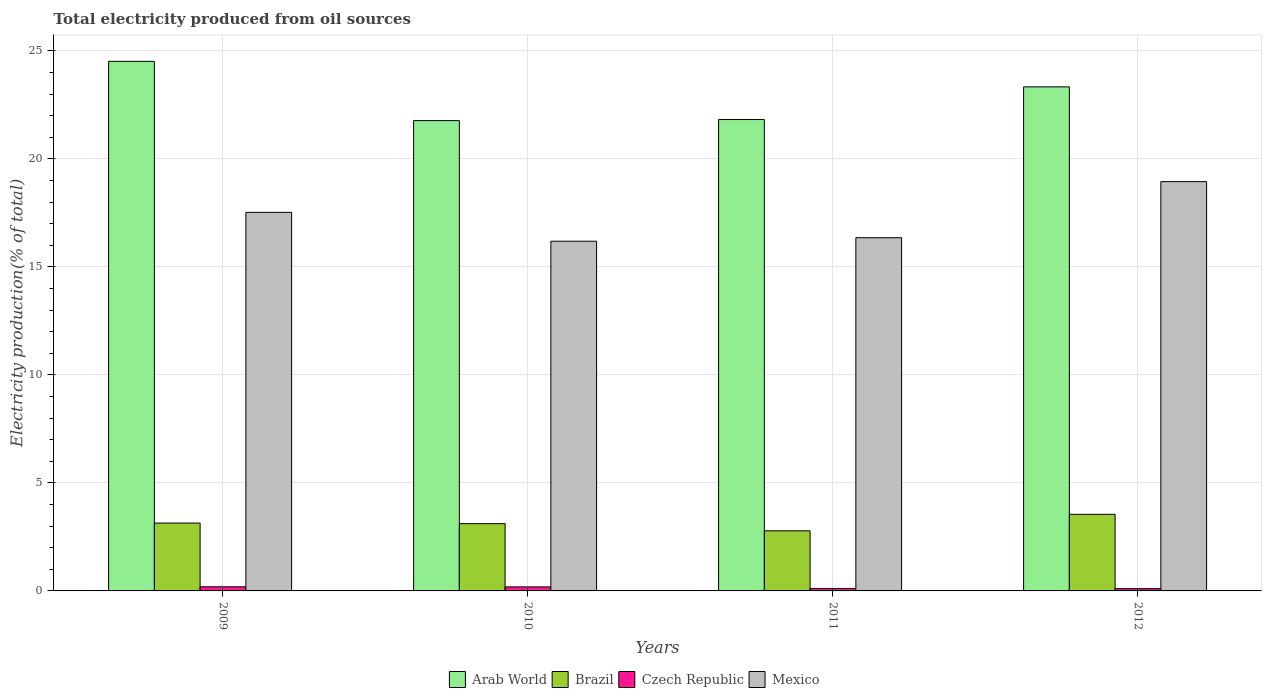How many different coloured bars are there?
Give a very brief answer. 4. How many groups of bars are there?
Ensure brevity in your answer.  4. Are the number of bars per tick equal to the number of legend labels?
Your answer should be very brief. Yes. Are the number of bars on each tick of the X-axis equal?
Offer a very short reply. Yes. How many bars are there on the 3rd tick from the left?
Provide a short and direct response. 4. In how many cases, is the number of bars for a given year not equal to the number of legend labels?
Offer a very short reply. 0. What is the total electricity produced in Brazil in 2012?
Provide a short and direct response. 3.55. Across all years, what is the maximum total electricity produced in Czech Republic?
Ensure brevity in your answer.  0.19. Across all years, what is the minimum total electricity produced in Czech Republic?
Your answer should be very brief. 0.1. In which year was the total electricity produced in Arab World maximum?
Keep it short and to the point. 2009. In which year was the total electricity produced in Arab World minimum?
Give a very brief answer. 2010. What is the total total electricity produced in Czech Republic in the graph?
Ensure brevity in your answer.  0.6. What is the difference between the total electricity produced in Arab World in 2011 and that in 2012?
Provide a succinct answer. -1.51. What is the difference between the total electricity produced in Czech Republic in 2011 and the total electricity produced in Mexico in 2010?
Provide a succinct answer. -16.07. What is the average total electricity produced in Arab World per year?
Your answer should be compact. 22.86. In the year 2011, what is the difference between the total electricity produced in Mexico and total electricity produced in Brazil?
Your answer should be compact. 13.57. What is the ratio of the total electricity produced in Arab World in 2011 to that in 2012?
Make the answer very short. 0.94. Is the difference between the total electricity produced in Mexico in 2009 and 2011 greater than the difference between the total electricity produced in Brazil in 2009 and 2011?
Give a very brief answer. Yes. What is the difference between the highest and the second highest total electricity produced in Mexico?
Give a very brief answer. 1.42. What is the difference between the highest and the lowest total electricity produced in Czech Republic?
Keep it short and to the point. 0.09. Is the sum of the total electricity produced in Czech Republic in 2009 and 2011 greater than the maximum total electricity produced in Arab World across all years?
Your response must be concise. No. Is it the case that in every year, the sum of the total electricity produced in Czech Republic and total electricity produced in Mexico is greater than the sum of total electricity produced in Arab World and total electricity produced in Brazil?
Give a very brief answer. Yes. What does the 4th bar from the left in 2009 represents?
Keep it short and to the point. Mexico. What does the 4th bar from the right in 2012 represents?
Offer a very short reply. Arab World. How many bars are there?
Make the answer very short. 16. Are all the bars in the graph horizontal?
Provide a succinct answer. No. What is the difference between two consecutive major ticks on the Y-axis?
Offer a very short reply. 5. Does the graph contain any zero values?
Provide a succinct answer. No. What is the title of the graph?
Provide a short and direct response. Total electricity produced from oil sources. What is the label or title of the X-axis?
Your response must be concise. Years. What is the label or title of the Y-axis?
Offer a very short reply. Electricity production(% of total). What is the Electricity production(% of total) in Arab World in 2009?
Provide a succinct answer. 24.51. What is the Electricity production(% of total) in Brazil in 2009?
Make the answer very short. 3.14. What is the Electricity production(% of total) in Czech Republic in 2009?
Provide a short and direct response. 0.19. What is the Electricity production(% of total) of Mexico in 2009?
Offer a very short reply. 17.52. What is the Electricity production(% of total) in Arab World in 2010?
Give a very brief answer. 21.77. What is the Electricity production(% of total) of Brazil in 2010?
Ensure brevity in your answer.  3.11. What is the Electricity production(% of total) of Czech Republic in 2010?
Your answer should be very brief. 0.19. What is the Electricity production(% of total) of Mexico in 2010?
Offer a terse response. 16.19. What is the Electricity production(% of total) of Arab World in 2011?
Offer a terse response. 21.82. What is the Electricity production(% of total) of Brazil in 2011?
Make the answer very short. 2.78. What is the Electricity production(% of total) in Czech Republic in 2011?
Provide a succinct answer. 0.11. What is the Electricity production(% of total) in Mexico in 2011?
Keep it short and to the point. 16.35. What is the Electricity production(% of total) of Arab World in 2012?
Your answer should be compact. 23.33. What is the Electricity production(% of total) of Brazil in 2012?
Ensure brevity in your answer.  3.55. What is the Electricity production(% of total) of Czech Republic in 2012?
Your answer should be compact. 0.1. What is the Electricity production(% of total) of Mexico in 2012?
Ensure brevity in your answer.  18.95. Across all years, what is the maximum Electricity production(% of total) of Arab World?
Give a very brief answer. 24.51. Across all years, what is the maximum Electricity production(% of total) of Brazil?
Keep it short and to the point. 3.55. Across all years, what is the maximum Electricity production(% of total) of Czech Republic?
Keep it short and to the point. 0.19. Across all years, what is the maximum Electricity production(% of total) of Mexico?
Your answer should be very brief. 18.95. Across all years, what is the minimum Electricity production(% of total) of Arab World?
Your answer should be compact. 21.77. Across all years, what is the minimum Electricity production(% of total) of Brazil?
Make the answer very short. 2.78. Across all years, what is the minimum Electricity production(% of total) of Czech Republic?
Your answer should be very brief. 0.1. Across all years, what is the minimum Electricity production(% of total) in Mexico?
Ensure brevity in your answer.  16.19. What is the total Electricity production(% of total) in Arab World in the graph?
Ensure brevity in your answer.  91.44. What is the total Electricity production(% of total) in Brazil in the graph?
Ensure brevity in your answer.  12.58. What is the total Electricity production(% of total) in Czech Republic in the graph?
Provide a short and direct response. 0.6. What is the total Electricity production(% of total) in Mexico in the graph?
Keep it short and to the point. 69.01. What is the difference between the Electricity production(% of total) in Arab World in 2009 and that in 2010?
Your answer should be very brief. 2.74. What is the difference between the Electricity production(% of total) of Brazil in 2009 and that in 2010?
Keep it short and to the point. 0.03. What is the difference between the Electricity production(% of total) of Czech Republic in 2009 and that in 2010?
Provide a succinct answer. 0. What is the difference between the Electricity production(% of total) of Mexico in 2009 and that in 2010?
Give a very brief answer. 1.34. What is the difference between the Electricity production(% of total) in Arab World in 2009 and that in 2011?
Your response must be concise. 2.69. What is the difference between the Electricity production(% of total) of Brazil in 2009 and that in 2011?
Provide a short and direct response. 0.36. What is the difference between the Electricity production(% of total) in Czech Republic in 2009 and that in 2011?
Your answer should be very brief. 0.08. What is the difference between the Electricity production(% of total) of Mexico in 2009 and that in 2011?
Provide a short and direct response. 1.17. What is the difference between the Electricity production(% of total) of Arab World in 2009 and that in 2012?
Your answer should be compact. 1.18. What is the difference between the Electricity production(% of total) of Brazil in 2009 and that in 2012?
Your answer should be very brief. -0.41. What is the difference between the Electricity production(% of total) of Czech Republic in 2009 and that in 2012?
Give a very brief answer. 0.09. What is the difference between the Electricity production(% of total) in Mexico in 2009 and that in 2012?
Ensure brevity in your answer.  -1.42. What is the difference between the Electricity production(% of total) in Arab World in 2010 and that in 2011?
Offer a very short reply. -0.05. What is the difference between the Electricity production(% of total) in Brazil in 2010 and that in 2011?
Offer a terse response. 0.33. What is the difference between the Electricity production(% of total) of Czech Republic in 2010 and that in 2011?
Offer a terse response. 0.07. What is the difference between the Electricity production(% of total) in Mexico in 2010 and that in 2011?
Offer a terse response. -0.16. What is the difference between the Electricity production(% of total) of Arab World in 2010 and that in 2012?
Offer a terse response. -1.56. What is the difference between the Electricity production(% of total) in Brazil in 2010 and that in 2012?
Ensure brevity in your answer.  -0.43. What is the difference between the Electricity production(% of total) in Czech Republic in 2010 and that in 2012?
Your answer should be very brief. 0.08. What is the difference between the Electricity production(% of total) of Mexico in 2010 and that in 2012?
Your answer should be very brief. -2.76. What is the difference between the Electricity production(% of total) of Arab World in 2011 and that in 2012?
Ensure brevity in your answer.  -1.51. What is the difference between the Electricity production(% of total) of Brazil in 2011 and that in 2012?
Give a very brief answer. -0.76. What is the difference between the Electricity production(% of total) in Czech Republic in 2011 and that in 2012?
Provide a short and direct response. 0.01. What is the difference between the Electricity production(% of total) of Mexico in 2011 and that in 2012?
Offer a very short reply. -2.6. What is the difference between the Electricity production(% of total) of Arab World in 2009 and the Electricity production(% of total) of Brazil in 2010?
Your answer should be very brief. 21.4. What is the difference between the Electricity production(% of total) in Arab World in 2009 and the Electricity production(% of total) in Czech Republic in 2010?
Provide a short and direct response. 24.33. What is the difference between the Electricity production(% of total) of Arab World in 2009 and the Electricity production(% of total) of Mexico in 2010?
Offer a terse response. 8.33. What is the difference between the Electricity production(% of total) in Brazil in 2009 and the Electricity production(% of total) in Czech Republic in 2010?
Offer a terse response. 2.95. What is the difference between the Electricity production(% of total) in Brazil in 2009 and the Electricity production(% of total) in Mexico in 2010?
Keep it short and to the point. -13.05. What is the difference between the Electricity production(% of total) of Czech Republic in 2009 and the Electricity production(% of total) of Mexico in 2010?
Provide a short and direct response. -16. What is the difference between the Electricity production(% of total) in Arab World in 2009 and the Electricity production(% of total) in Brazil in 2011?
Provide a short and direct response. 21.73. What is the difference between the Electricity production(% of total) of Arab World in 2009 and the Electricity production(% of total) of Czech Republic in 2011?
Give a very brief answer. 24.4. What is the difference between the Electricity production(% of total) in Arab World in 2009 and the Electricity production(% of total) in Mexico in 2011?
Offer a terse response. 8.16. What is the difference between the Electricity production(% of total) of Brazil in 2009 and the Electricity production(% of total) of Czech Republic in 2011?
Your answer should be compact. 3.03. What is the difference between the Electricity production(% of total) in Brazil in 2009 and the Electricity production(% of total) in Mexico in 2011?
Offer a very short reply. -13.21. What is the difference between the Electricity production(% of total) of Czech Republic in 2009 and the Electricity production(% of total) of Mexico in 2011?
Keep it short and to the point. -16.16. What is the difference between the Electricity production(% of total) of Arab World in 2009 and the Electricity production(% of total) of Brazil in 2012?
Offer a very short reply. 20.97. What is the difference between the Electricity production(% of total) in Arab World in 2009 and the Electricity production(% of total) in Czech Republic in 2012?
Give a very brief answer. 24.41. What is the difference between the Electricity production(% of total) of Arab World in 2009 and the Electricity production(% of total) of Mexico in 2012?
Provide a succinct answer. 5.57. What is the difference between the Electricity production(% of total) of Brazil in 2009 and the Electricity production(% of total) of Czech Republic in 2012?
Provide a short and direct response. 3.04. What is the difference between the Electricity production(% of total) in Brazil in 2009 and the Electricity production(% of total) in Mexico in 2012?
Your answer should be compact. -15.81. What is the difference between the Electricity production(% of total) of Czech Republic in 2009 and the Electricity production(% of total) of Mexico in 2012?
Provide a short and direct response. -18.76. What is the difference between the Electricity production(% of total) in Arab World in 2010 and the Electricity production(% of total) in Brazil in 2011?
Offer a terse response. 18.99. What is the difference between the Electricity production(% of total) of Arab World in 2010 and the Electricity production(% of total) of Czech Republic in 2011?
Make the answer very short. 21.66. What is the difference between the Electricity production(% of total) of Arab World in 2010 and the Electricity production(% of total) of Mexico in 2011?
Keep it short and to the point. 5.42. What is the difference between the Electricity production(% of total) in Brazil in 2010 and the Electricity production(% of total) in Czech Republic in 2011?
Give a very brief answer. 3. What is the difference between the Electricity production(% of total) of Brazil in 2010 and the Electricity production(% of total) of Mexico in 2011?
Keep it short and to the point. -13.24. What is the difference between the Electricity production(% of total) of Czech Republic in 2010 and the Electricity production(% of total) of Mexico in 2011?
Provide a short and direct response. -16.16. What is the difference between the Electricity production(% of total) of Arab World in 2010 and the Electricity production(% of total) of Brazil in 2012?
Keep it short and to the point. 18.22. What is the difference between the Electricity production(% of total) in Arab World in 2010 and the Electricity production(% of total) in Czech Republic in 2012?
Provide a succinct answer. 21.67. What is the difference between the Electricity production(% of total) in Arab World in 2010 and the Electricity production(% of total) in Mexico in 2012?
Offer a very short reply. 2.82. What is the difference between the Electricity production(% of total) of Brazil in 2010 and the Electricity production(% of total) of Czech Republic in 2012?
Ensure brevity in your answer.  3.01. What is the difference between the Electricity production(% of total) of Brazil in 2010 and the Electricity production(% of total) of Mexico in 2012?
Provide a succinct answer. -15.83. What is the difference between the Electricity production(% of total) in Czech Republic in 2010 and the Electricity production(% of total) in Mexico in 2012?
Give a very brief answer. -18.76. What is the difference between the Electricity production(% of total) of Arab World in 2011 and the Electricity production(% of total) of Brazil in 2012?
Your answer should be compact. 18.27. What is the difference between the Electricity production(% of total) of Arab World in 2011 and the Electricity production(% of total) of Czech Republic in 2012?
Your answer should be compact. 21.72. What is the difference between the Electricity production(% of total) in Arab World in 2011 and the Electricity production(% of total) in Mexico in 2012?
Your answer should be compact. 2.87. What is the difference between the Electricity production(% of total) of Brazil in 2011 and the Electricity production(% of total) of Czech Republic in 2012?
Your answer should be compact. 2.68. What is the difference between the Electricity production(% of total) of Brazil in 2011 and the Electricity production(% of total) of Mexico in 2012?
Give a very brief answer. -16.16. What is the difference between the Electricity production(% of total) in Czech Republic in 2011 and the Electricity production(% of total) in Mexico in 2012?
Keep it short and to the point. -18.83. What is the average Electricity production(% of total) of Arab World per year?
Your response must be concise. 22.86. What is the average Electricity production(% of total) in Brazil per year?
Keep it short and to the point. 3.15. What is the average Electricity production(% of total) in Czech Republic per year?
Your response must be concise. 0.15. What is the average Electricity production(% of total) of Mexico per year?
Give a very brief answer. 17.25. In the year 2009, what is the difference between the Electricity production(% of total) of Arab World and Electricity production(% of total) of Brazil?
Offer a terse response. 21.37. In the year 2009, what is the difference between the Electricity production(% of total) in Arab World and Electricity production(% of total) in Czech Republic?
Your response must be concise. 24.32. In the year 2009, what is the difference between the Electricity production(% of total) of Arab World and Electricity production(% of total) of Mexico?
Provide a short and direct response. 6.99. In the year 2009, what is the difference between the Electricity production(% of total) in Brazil and Electricity production(% of total) in Czech Republic?
Your answer should be compact. 2.95. In the year 2009, what is the difference between the Electricity production(% of total) of Brazil and Electricity production(% of total) of Mexico?
Your answer should be compact. -14.38. In the year 2009, what is the difference between the Electricity production(% of total) in Czech Republic and Electricity production(% of total) in Mexico?
Your response must be concise. -17.33. In the year 2010, what is the difference between the Electricity production(% of total) in Arab World and Electricity production(% of total) in Brazil?
Provide a succinct answer. 18.66. In the year 2010, what is the difference between the Electricity production(% of total) in Arab World and Electricity production(% of total) in Czech Republic?
Provide a short and direct response. 21.58. In the year 2010, what is the difference between the Electricity production(% of total) in Arab World and Electricity production(% of total) in Mexico?
Your answer should be very brief. 5.58. In the year 2010, what is the difference between the Electricity production(% of total) of Brazil and Electricity production(% of total) of Czech Republic?
Your response must be concise. 2.93. In the year 2010, what is the difference between the Electricity production(% of total) of Brazil and Electricity production(% of total) of Mexico?
Your answer should be compact. -13.07. In the year 2010, what is the difference between the Electricity production(% of total) in Czech Republic and Electricity production(% of total) in Mexico?
Ensure brevity in your answer.  -16. In the year 2011, what is the difference between the Electricity production(% of total) in Arab World and Electricity production(% of total) in Brazil?
Give a very brief answer. 19.04. In the year 2011, what is the difference between the Electricity production(% of total) of Arab World and Electricity production(% of total) of Czech Republic?
Your response must be concise. 21.71. In the year 2011, what is the difference between the Electricity production(% of total) of Arab World and Electricity production(% of total) of Mexico?
Make the answer very short. 5.47. In the year 2011, what is the difference between the Electricity production(% of total) of Brazil and Electricity production(% of total) of Czech Republic?
Your answer should be compact. 2.67. In the year 2011, what is the difference between the Electricity production(% of total) of Brazil and Electricity production(% of total) of Mexico?
Offer a terse response. -13.57. In the year 2011, what is the difference between the Electricity production(% of total) of Czech Republic and Electricity production(% of total) of Mexico?
Your response must be concise. -16.24. In the year 2012, what is the difference between the Electricity production(% of total) in Arab World and Electricity production(% of total) in Brazil?
Give a very brief answer. 19.79. In the year 2012, what is the difference between the Electricity production(% of total) of Arab World and Electricity production(% of total) of Czech Republic?
Provide a short and direct response. 23.23. In the year 2012, what is the difference between the Electricity production(% of total) of Arab World and Electricity production(% of total) of Mexico?
Offer a very short reply. 4.39. In the year 2012, what is the difference between the Electricity production(% of total) in Brazil and Electricity production(% of total) in Czech Republic?
Your response must be concise. 3.44. In the year 2012, what is the difference between the Electricity production(% of total) of Brazil and Electricity production(% of total) of Mexico?
Make the answer very short. -15.4. In the year 2012, what is the difference between the Electricity production(% of total) of Czech Republic and Electricity production(% of total) of Mexico?
Keep it short and to the point. -18.84. What is the ratio of the Electricity production(% of total) in Arab World in 2009 to that in 2010?
Provide a succinct answer. 1.13. What is the ratio of the Electricity production(% of total) in Brazil in 2009 to that in 2010?
Offer a terse response. 1.01. What is the ratio of the Electricity production(% of total) of Czech Republic in 2009 to that in 2010?
Ensure brevity in your answer.  1.02. What is the ratio of the Electricity production(% of total) in Mexico in 2009 to that in 2010?
Offer a terse response. 1.08. What is the ratio of the Electricity production(% of total) of Arab World in 2009 to that in 2011?
Give a very brief answer. 1.12. What is the ratio of the Electricity production(% of total) of Brazil in 2009 to that in 2011?
Provide a short and direct response. 1.13. What is the ratio of the Electricity production(% of total) of Czech Republic in 2009 to that in 2011?
Make the answer very short. 1.68. What is the ratio of the Electricity production(% of total) of Mexico in 2009 to that in 2011?
Your response must be concise. 1.07. What is the ratio of the Electricity production(% of total) in Arab World in 2009 to that in 2012?
Your response must be concise. 1.05. What is the ratio of the Electricity production(% of total) of Brazil in 2009 to that in 2012?
Provide a short and direct response. 0.89. What is the ratio of the Electricity production(% of total) of Czech Republic in 2009 to that in 2012?
Your response must be concise. 1.82. What is the ratio of the Electricity production(% of total) of Mexico in 2009 to that in 2012?
Offer a terse response. 0.92. What is the ratio of the Electricity production(% of total) of Brazil in 2010 to that in 2011?
Keep it short and to the point. 1.12. What is the ratio of the Electricity production(% of total) in Czech Republic in 2010 to that in 2011?
Provide a succinct answer. 1.64. What is the ratio of the Electricity production(% of total) in Arab World in 2010 to that in 2012?
Provide a short and direct response. 0.93. What is the ratio of the Electricity production(% of total) in Brazil in 2010 to that in 2012?
Your response must be concise. 0.88. What is the ratio of the Electricity production(% of total) of Czech Republic in 2010 to that in 2012?
Give a very brief answer. 1.78. What is the ratio of the Electricity production(% of total) of Mexico in 2010 to that in 2012?
Ensure brevity in your answer.  0.85. What is the ratio of the Electricity production(% of total) in Arab World in 2011 to that in 2012?
Make the answer very short. 0.94. What is the ratio of the Electricity production(% of total) in Brazil in 2011 to that in 2012?
Keep it short and to the point. 0.78. What is the ratio of the Electricity production(% of total) in Czech Republic in 2011 to that in 2012?
Your answer should be compact. 1.09. What is the ratio of the Electricity production(% of total) in Mexico in 2011 to that in 2012?
Give a very brief answer. 0.86. What is the difference between the highest and the second highest Electricity production(% of total) in Arab World?
Your answer should be very brief. 1.18. What is the difference between the highest and the second highest Electricity production(% of total) in Brazil?
Offer a very short reply. 0.41. What is the difference between the highest and the second highest Electricity production(% of total) of Czech Republic?
Offer a very short reply. 0. What is the difference between the highest and the second highest Electricity production(% of total) of Mexico?
Offer a very short reply. 1.42. What is the difference between the highest and the lowest Electricity production(% of total) of Arab World?
Your answer should be compact. 2.74. What is the difference between the highest and the lowest Electricity production(% of total) of Brazil?
Give a very brief answer. 0.76. What is the difference between the highest and the lowest Electricity production(% of total) of Czech Republic?
Provide a short and direct response. 0.09. What is the difference between the highest and the lowest Electricity production(% of total) of Mexico?
Keep it short and to the point. 2.76. 